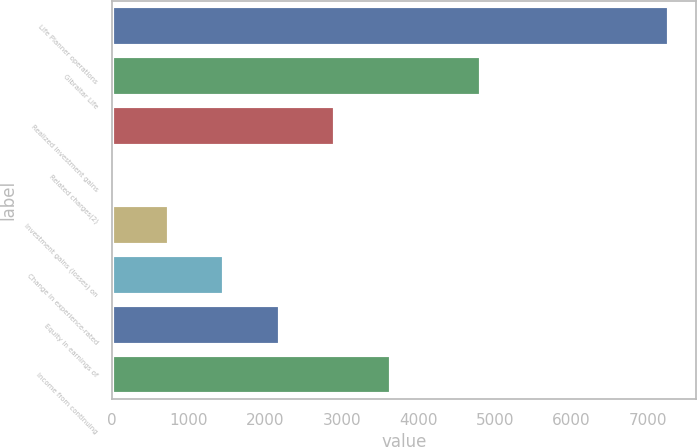Convert chart. <chart><loc_0><loc_0><loc_500><loc_500><bar_chart><fcel>Life Planner operations<fcel>Gibraltar Life<fcel>Realized investment gains<fcel>Related charges(2)<fcel>Investment gains (losses) on<fcel>Change in experience-rated<fcel>Equity in earnings of<fcel>Income from continuing<nl><fcel>7266<fcel>4823<fcel>2915.4<fcel>15<fcel>740.1<fcel>1465.2<fcel>2190.3<fcel>3640.5<nl></chart> 